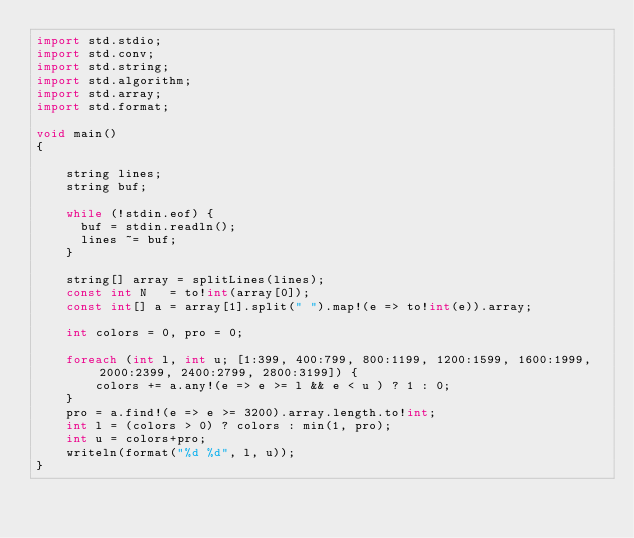<code> <loc_0><loc_0><loc_500><loc_500><_D_>import std.stdio;
import std.conv;
import std.string;
import std.algorithm;
import std.array;
import std.format;
 
void main()
{

    string lines;
    string buf;
 
    while (!stdin.eof) {
      buf = stdin.readln();
      lines ~= buf;
    }

    string[] array = splitLines(lines);
    const int N   = to!int(array[0]);
    const int[] a = array[1].split(" ").map!(e => to!int(e)).array;
    
    int colors = 0, pro = 0;
    
    foreach (int l, int u; [1:399, 400:799, 800:1199, 1200:1599, 1600:1999, 2000:2399, 2400:2799, 2800:3199]) {
        colors += a.any!(e => e >= l && e < u ) ? 1 : 0;
    }
    pro = a.find!(e => e >= 3200).array.length.to!int;
    int l = (colors > 0) ? colors : min(1, pro);
    int u = colors+pro;
    writeln(format("%d %d", l, u));
}</code> 